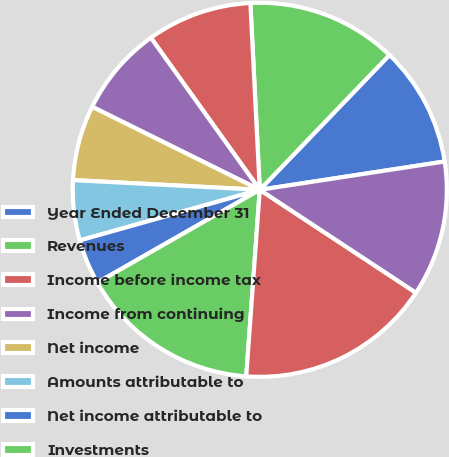Convert chart. <chart><loc_0><loc_0><loc_500><loc_500><pie_chart><fcel>Year Ended December 31<fcel>Revenues<fcel>Income before income tax<fcel>Income from continuing<fcel>Net income<fcel>Amounts attributable to<fcel>Net income attributable to<fcel>Investments<fcel>Total assets<fcel>Debt<nl><fcel>10.39%<fcel>12.99%<fcel>9.09%<fcel>7.79%<fcel>6.49%<fcel>5.19%<fcel>3.9%<fcel>15.58%<fcel>16.88%<fcel>11.69%<nl></chart> 